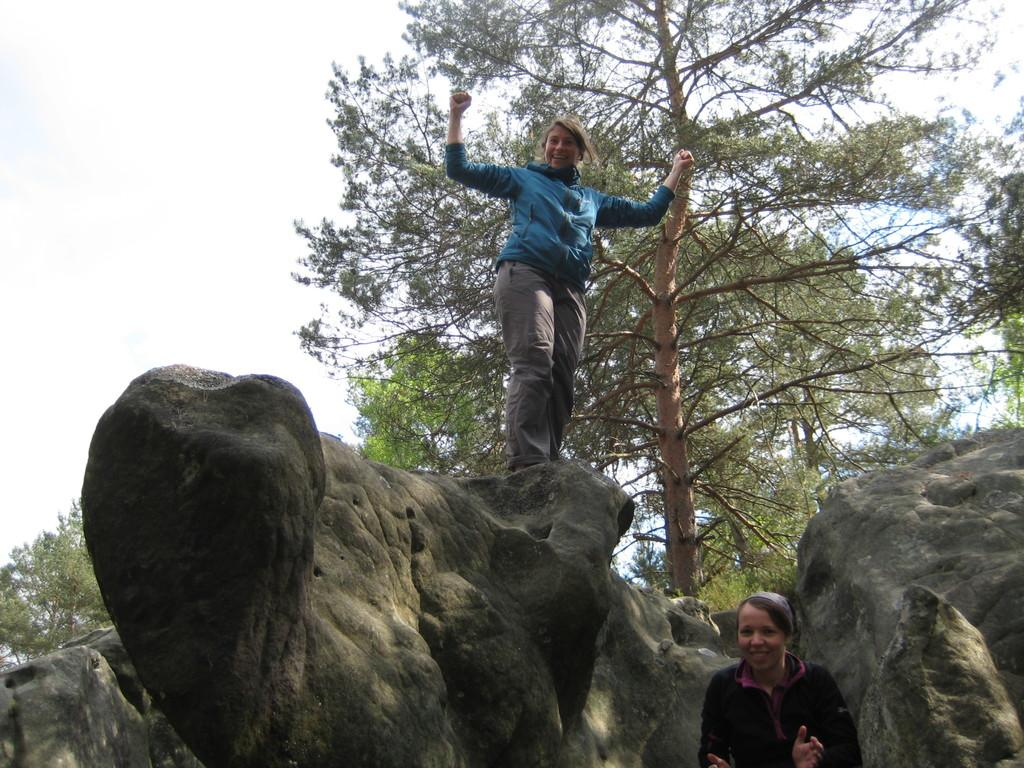What is the main object in the image? There is a huge stone in the image. What are the women doing in the image? One woman is standing on the stone, and another woman is standing on the ground beside the stone. What can be seen in the background of the image? There are many trees beside the stone. What type of stamp can be seen on the stone in the image? There is no stamp present on the stone in the image. Can you describe the conversation between the women in the image? There is no conversation between the women in the image; they are simply standing in their respective positions. 